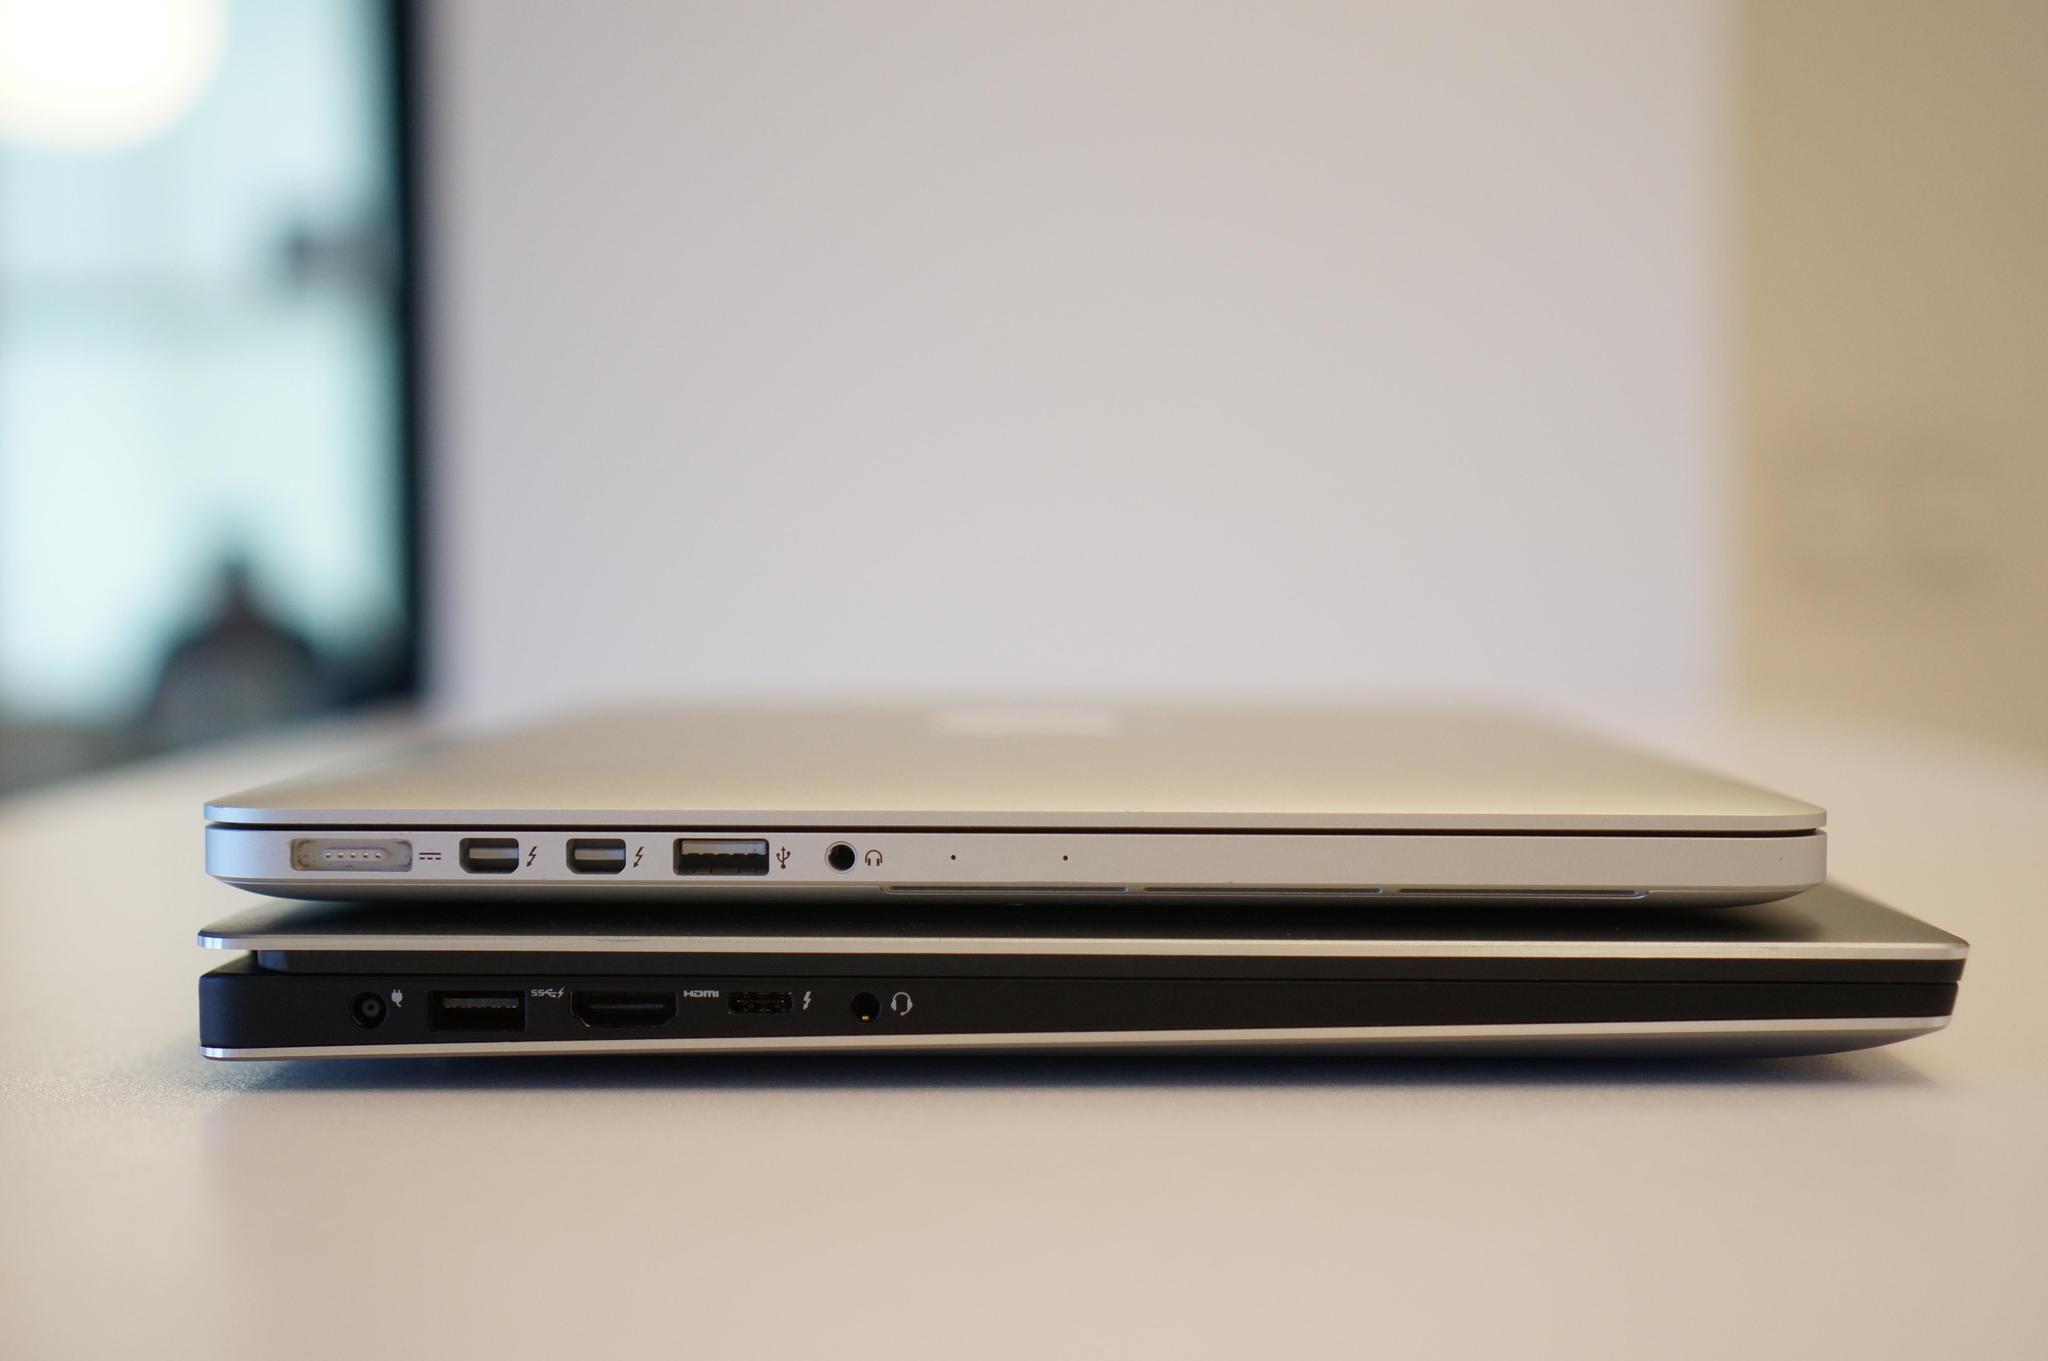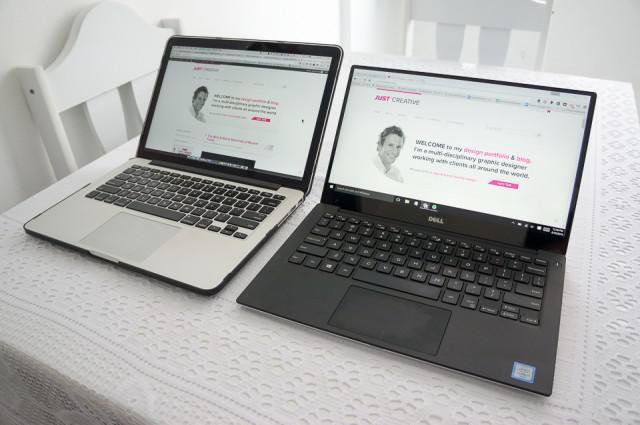The first image is the image on the left, the second image is the image on the right. Analyze the images presented: Is the assertion "The left image features one closed laptop stacked on another, and the right image shows side-by-side open laptops." valid? Answer yes or no. Yes. The first image is the image on the left, the second image is the image on the right. Considering the images on both sides, is "In the image on the right 2 laptops are placed side by side." valid? Answer yes or no. Yes. 